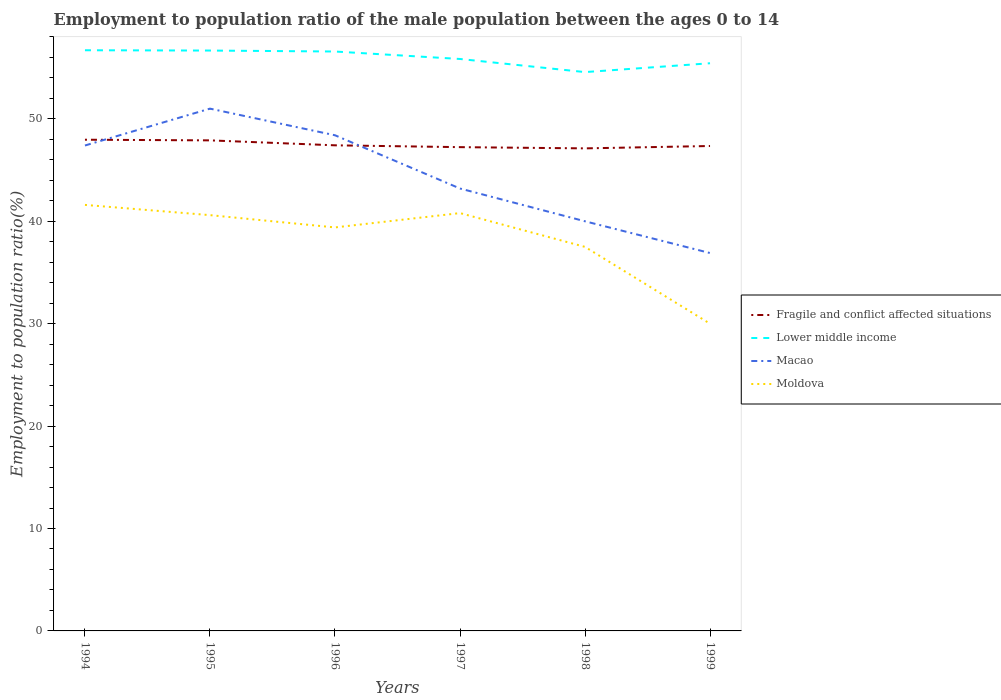Across all years, what is the maximum employment to population ratio in Fragile and conflict affected situations?
Ensure brevity in your answer.  47.12. What is the total employment to population ratio in Moldova in the graph?
Offer a terse response. -0.2. What is the difference between the highest and the second highest employment to population ratio in Macao?
Your response must be concise. 14.1. Is the employment to population ratio in Fragile and conflict affected situations strictly greater than the employment to population ratio in Macao over the years?
Ensure brevity in your answer.  No. What is the difference between two consecutive major ticks on the Y-axis?
Keep it short and to the point. 10. Where does the legend appear in the graph?
Provide a short and direct response. Center right. How many legend labels are there?
Ensure brevity in your answer.  4. How are the legend labels stacked?
Your response must be concise. Vertical. What is the title of the graph?
Your response must be concise. Employment to population ratio of the male population between the ages 0 to 14. What is the Employment to population ratio(%) in Fragile and conflict affected situations in 1994?
Give a very brief answer. 47.96. What is the Employment to population ratio(%) of Lower middle income in 1994?
Provide a short and direct response. 56.7. What is the Employment to population ratio(%) of Macao in 1994?
Your answer should be compact. 47.4. What is the Employment to population ratio(%) of Moldova in 1994?
Offer a terse response. 41.6. What is the Employment to population ratio(%) in Fragile and conflict affected situations in 1995?
Your response must be concise. 47.9. What is the Employment to population ratio(%) of Lower middle income in 1995?
Your answer should be very brief. 56.67. What is the Employment to population ratio(%) in Macao in 1995?
Offer a very short reply. 51. What is the Employment to population ratio(%) of Moldova in 1995?
Provide a succinct answer. 40.6. What is the Employment to population ratio(%) in Fragile and conflict affected situations in 1996?
Offer a very short reply. 47.42. What is the Employment to population ratio(%) in Lower middle income in 1996?
Provide a short and direct response. 56.58. What is the Employment to population ratio(%) in Macao in 1996?
Your answer should be very brief. 48.4. What is the Employment to population ratio(%) in Moldova in 1996?
Give a very brief answer. 39.4. What is the Employment to population ratio(%) in Fragile and conflict affected situations in 1997?
Give a very brief answer. 47.24. What is the Employment to population ratio(%) in Lower middle income in 1997?
Offer a terse response. 55.85. What is the Employment to population ratio(%) of Macao in 1997?
Provide a short and direct response. 43.2. What is the Employment to population ratio(%) in Moldova in 1997?
Ensure brevity in your answer.  40.8. What is the Employment to population ratio(%) of Fragile and conflict affected situations in 1998?
Provide a short and direct response. 47.12. What is the Employment to population ratio(%) in Lower middle income in 1998?
Make the answer very short. 54.57. What is the Employment to population ratio(%) in Macao in 1998?
Offer a very short reply. 40. What is the Employment to population ratio(%) in Moldova in 1998?
Offer a terse response. 37.5. What is the Employment to population ratio(%) of Fragile and conflict affected situations in 1999?
Offer a very short reply. 47.35. What is the Employment to population ratio(%) of Lower middle income in 1999?
Provide a succinct answer. 55.43. What is the Employment to population ratio(%) in Macao in 1999?
Your answer should be very brief. 36.9. Across all years, what is the maximum Employment to population ratio(%) in Fragile and conflict affected situations?
Offer a terse response. 47.96. Across all years, what is the maximum Employment to population ratio(%) of Lower middle income?
Your answer should be compact. 56.7. Across all years, what is the maximum Employment to population ratio(%) in Macao?
Offer a terse response. 51. Across all years, what is the maximum Employment to population ratio(%) in Moldova?
Offer a terse response. 41.6. Across all years, what is the minimum Employment to population ratio(%) of Fragile and conflict affected situations?
Your answer should be compact. 47.12. Across all years, what is the minimum Employment to population ratio(%) of Lower middle income?
Ensure brevity in your answer.  54.57. Across all years, what is the minimum Employment to population ratio(%) in Macao?
Provide a short and direct response. 36.9. Across all years, what is the minimum Employment to population ratio(%) of Moldova?
Make the answer very short. 30. What is the total Employment to population ratio(%) in Fragile and conflict affected situations in the graph?
Give a very brief answer. 284.99. What is the total Employment to population ratio(%) in Lower middle income in the graph?
Offer a very short reply. 335.8. What is the total Employment to population ratio(%) of Macao in the graph?
Your answer should be very brief. 266.9. What is the total Employment to population ratio(%) of Moldova in the graph?
Provide a short and direct response. 229.9. What is the difference between the Employment to population ratio(%) of Fragile and conflict affected situations in 1994 and that in 1995?
Your answer should be very brief. 0.06. What is the difference between the Employment to population ratio(%) of Lower middle income in 1994 and that in 1995?
Ensure brevity in your answer.  0.03. What is the difference between the Employment to population ratio(%) of Fragile and conflict affected situations in 1994 and that in 1996?
Offer a terse response. 0.55. What is the difference between the Employment to population ratio(%) in Lower middle income in 1994 and that in 1996?
Give a very brief answer. 0.12. What is the difference between the Employment to population ratio(%) in Macao in 1994 and that in 1996?
Offer a very short reply. -1. What is the difference between the Employment to population ratio(%) in Fragile and conflict affected situations in 1994 and that in 1997?
Make the answer very short. 0.73. What is the difference between the Employment to population ratio(%) in Lower middle income in 1994 and that in 1997?
Give a very brief answer. 0.85. What is the difference between the Employment to population ratio(%) in Fragile and conflict affected situations in 1994 and that in 1998?
Provide a succinct answer. 0.85. What is the difference between the Employment to population ratio(%) of Lower middle income in 1994 and that in 1998?
Give a very brief answer. 2.13. What is the difference between the Employment to population ratio(%) of Moldova in 1994 and that in 1998?
Provide a succinct answer. 4.1. What is the difference between the Employment to population ratio(%) of Fragile and conflict affected situations in 1994 and that in 1999?
Your answer should be compact. 0.61. What is the difference between the Employment to population ratio(%) of Lower middle income in 1994 and that in 1999?
Offer a very short reply. 1.27. What is the difference between the Employment to population ratio(%) of Macao in 1994 and that in 1999?
Provide a succinct answer. 10.5. What is the difference between the Employment to population ratio(%) in Fragile and conflict affected situations in 1995 and that in 1996?
Your answer should be compact. 0.48. What is the difference between the Employment to population ratio(%) in Lower middle income in 1995 and that in 1996?
Provide a succinct answer. 0.09. What is the difference between the Employment to population ratio(%) in Macao in 1995 and that in 1996?
Make the answer very short. 2.6. What is the difference between the Employment to population ratio(%) of Fragile and conflict affected situations in 1995 and that in 1997?
Your response must be concise. 0.66. What is the difference between the Employment to population ratio(%) of Lower middle income in 1995 and that in 1997?
Your answer should be very brief. 0.82. What is the difference between the Employment to population ratio(%) of Macao in 1995 and that in 1997?
Make the answer very short. 7.8. What is the difference between the Employment to population ratio(%) of Moldova in 1995 and that in 1997?
Keep it short and to the point. -0.2. What is the difference between the Employment to population ratio(%) of Fragile and conflict affected situations in 1995 and that in 1998?
Your answer should be compact. 0.78. What is the difference between the Employment to population ratio(%) in Lower middle income in 1995 and that in 1998?
Offer a very short reply. 2.1. What is the difference between the Employment to population ratio(%) of Macao in 1995 and that in 1998?
Provide a succinct answer. 11. What is the difference between the Employment to population ratio(%) in Moldova in 1995 and that in 1998?
Keep it short and to the point. 3.1. What is the difference between the Employment to population ratio(%) in Fragile and conflict affected situations in 1995 and that in 1999?
Keep it short and to the point. 0.55. What is the difference between the Employment to population ratio(%) in Lower middle income in 1995 and that in 1999?
Your answer should be very brief. 1.24. What is the difference between the Employment to population ratio(%) of Macao in 1995 and that in 1999?
Provide a short and direct response. 14.1. What is the difference between the Employment to population ratio(%) of Fragile and conflict affected situations in 1996 and that in 1997?
Ensure brevity in your answer.  0.18. What is the difference between the Employment to population ratio(%) in Lower middle income in 1996 and that in 1997?
Offer a terse response. 0.73. What is the difference between the Employment to population ratio(%) of Fragile and conflict affected situations in 1996 and that in 1998?
Provide a short and direct response. 0.3. What is the difference between the Employment to population ratio(%) of Lower middle income in 1996 and that in 1998?
Provide a short and direct response. 2.01. What is the difference between the Employment to population ratio(%) in Fragile and conflict affected situations in 1996 and that in 1999?
Your answer should be very brief. 0.07. What is the difference between the Employment to population ratio(%) of Lower middle income in 1996 and that in 1999?
Make the answer very short. 1.15. What is the difference between the Employment to population ratio(%) in Fragile and conflict affected situations in 1997 and that in 1998?
Your answer should be compact. 0.12. What is the difference between the Employment to population ratio(%) of Lower middle income in 1997 and that in 1998?
Keep it short and to the point. 1.28. What is the difference between the Employment to population ratio(%) in Macao in 1997 and that in 1998?
Keep it short and to the point. 3.2. What is the difference between the Employment to population ratio(%) in Moldova in 1997 and that in 1998?
Make the answer very short. 3.3. What is the difference between the Employment to population ratio(%) in Fragile and conflict affected situations in 1997 and that in 1999?
Offer a very short reply. -0.11. What is the difference between the Employment to population ratio(%) in Lower middle income in 1997 and that in 1999?
Keep it short and to the point. 0.42. What is the difference between the Employment to population ratio(%) of Macao in 1997 and that in 1999?
Provide a succinct answer. 6.3. What is the difference between the Employment to population ratio(%) in Fragile and conflict affected situations in 1998 and that in 1999?
Your answer should be very brief. -0.23. What is the difference between the Employment to population ratio(%) of Lower middle income in 1998 and that in 1999?
Provide a short and direct response. -0.86. What is the difference between the Employment to population ratio(%) in Macao in 1998 and that in 1999?
Give a very brief answer. 3.1. What is the difference between the Employment to population ratio(%) of Moldova in 1998 and that in 1999?
Provide a succinct answer. 7.5. What is the difference between the Employment to population ratio(%) in Fragile and conflict affected situations in 1994 and the Employment to population ratio(%) in Lower middle income in 1995?
Give a very brief answer. -8.71. What is the difference between the Employment to population ratio(%) of Fragile and conflict affected situations in 1994 and the Employment to population ratio(%) of Macao in 1995?
Provide a succinct answer. -3.04. What is the difference between the Employment to population ratio(%) of Fragile and conflict affected situations in 1994 and the Employment to population ratio(%) of Moldova in 1995?
Your answer should be very brief. 7.37. What is the difference between the Employment to population ratio(%) of Lower middle income in 1994 and the Employment to population ratio(%) of Macao in 1995?
Make the answer very short. 5.7. What is the difference between the Employment to population ratio(%) of Lower middle income in 1994 and the Employment to population ratio(%) of Moldova in 1995?
Provide a short and direct response. 16.1. What is the difference between the Employment to population ratio(%) in Fragile and conflict affected situations in 1994 and the Employment to population ratio(%) in Lower middle income in 1996?
Give a very brief answer. -8.61. What is the difference between the Employment to population ratio(%) in Fragile and conflict affected situations in 1994 and the Employment to population ratio(%) in Macao in 1996?
Make the answer very short. -0.44. What is the difference between the Employment to population ratio(%) in Fragile and conflict affected situations in 1994 and the Employment to population ratio(%) in Moldova in 1996?
Offer a very short reply. 8.56. What is the difference between the Employment to population ratio(%) of Lower middle income in 1994 and the Employment to population ratio(%) of Macao in 1996?
Your response must be concise. 8.3. What is the difference between the Employment to population ratio(%) in Lower middle income in 1994 and the Employment to population ratio(%) in Moldova in 1996?
Provide a succinct answer. 17.3. What is the difference between the Employment to population ratio(%) in Macao in 1994 and the Employment to population ratio(%) in Moldova in 1996?
Give a very brief answer. 8. What is the difference between the Employment to population ratio(%) of Fragile and conflict affected situations in 1994 and the Employment to population ratio(%) of Lower middle income in 1997?
Offer a terse response. -7.88. What is the difference between the Employment to population ratio(%) of Fragile and conflict affected situations in 1994 and the Employment to population ratio(%) of Macao in 1997?
Make the answer very short. 4.76. What is the difference between the Employment to population ratio(%) in Fragile and conflict affected situations in 1994 and the Employment to population ratio(%) in Moldova in 1997?
Your response must be concise. 7.17. What is the difference between the Employment to population ratio(%) in Lower middle income in 1994 and the Employment to population ratio(%) in Macao in 1997?
Make the answer very short. 13.5. What is the difference between the Employment to population ratio(%) in Lower middle income in 1994 and the Employment to population ratio(%) in Moldova in 1997?
Provide a short and direct response. 15.9. What is the difference between the Employment to population ratio(%) of Macao in 1994 and the Employment to population ratio(%) of Moldova in 1997?
Offer a terse response. 6.6. What is the difference between the Employment to population ratio(%) of Fragile and conflict affected situations in 1994 and the Employment to population ratio(%) of Lower middle income in 1998?
Offer a very short reply. -6.6. What is the difference between the Employment to population ratio(%) of Fragile and conflict affected situations in 1994 and the Employment to population ratio(%) of Macao in 1998?
Your answer should be compact. 7.96. What is the difference between the Employment to population ratio(%) of Fragile and conflict affected situations in 1994 and the Employment to population ratio(%) of Moldova in 1998?
Offer a very short reply. 10.46. What is the difference between the Employment to population ratio(%) of Lower middle income in 1994 and the Employment to population ratio(%) of Macao in 1998?
Provide a short and direct response. 16.7. What is the difference between the Employment to population ratio(%) in Lower middle income in 1994 and the Employment to population ratio(%) in Moldova in 1998?
Keep it short and to the point. 19.2. What is the difference between the Employment to population ratio(%) in Macao in 1994 and the Employment to population ratio(%) in Moldova in 1998?
Your answer should be very brief. 9.9. What is the difference between the Employment to population ratio(%) in Fragile and conflict affected situations in 1994 and the Employment to population ratio(%) in Lower middle income in 1999?
Your answer should be very brief. -7.47. What is the difference between the Employment to population ratio(%) in Fragile and conflict affected situations in 1994 and the Employment to population ratio(%) in Macao in 1999?
Provide a succinct answer. 11.06. What is the difference between the Employment to population ratio(%) of Fragile and conflict affected situations in 1994 and the Employment to population ratio(%) of Moldova in 1999?
Offer a very short reply. 17.96. What is the difference between the Employment to population ratio(%) in Lower middle income in 1994 and the Employment to population ratio(%) in Macao in 1999?
Keep it short and to the point. 19.8. What is the difference between the Employment to population ratio(%) in Lower middle income in 1994 and the Employment to population ratio(%) in Moldova in 1999?
Your answer should be compact. 26.7. What is the difference between the Employment to population ratio(%) in Fragile and conflict affected situations in 1995 and the Employment to population ratio(%) in Lower middle income in 1996?
Provide a short and direct response. -8.68. What is the difference between the Employment to population ratio(%) in Fragile and conflict affected situations in 1995 and the Employment to population ratio(%) in Macao in 1996?
Make the answer very short. -0.5. What is the difference between the Employment to population ratio(%) of Fragile and conflict affected situations in 1995 and the Employment to population ratio(%) of Moldova in 1996?
Ensure brevity in your answer.  8.5. What is the difference between the Employment to population ratio(%) in Lower middle income in 1995 and the Employment to population ratio(%) in Macao in 1996?
Give a very brief answer. 8.27. What is the difference between the Employment to population ratio(%) in Lower middle income in 1995 and the Employment to population ratio(%) in Moldova in 1996?
Offer a very short reply. 17.27. What is the difference between the Employment to population ratio(%) in Macao in 1995 and the Employment to population ratio(%) in Moldova in 1996?
Provide a succinct answer. 11.6. What is the difference between the Employment to population ratio(%) in Fragile and conflict affected situations in 1995 and the Employment to population ratio(%) in Lower middle income in 1997?
Offer a very short reply. -7.95. What is the difference between the Employment to population ratio(%) of Fragile and conflict affected situations in 1995 and the Employment to population ratio(%) of Macao in 1997?
Offer a terse response. 4.7. What is the difference between the Employment to population ratio(%) of Fragile and conflict affected situations in 1995 and the Employment to population ratio(%) of Moldova in 1997?
Provide a short and direct response. 7.1. What is the difference between the Employment to population ratio(%) of Lower middle income in 1995 and the Employment to population ratio(%) of Macao in 1997?
Your response must be concise. 13.47. What is the difference between the Employment to population ratio(%) of Lower middle income in 1995 and the Employment to population ratio(%) of Moldova in 1997?
Your answer should be compact. 15.87. What is the difference between the Employment to population ratio(%) in Fragile and conflict affected situations in 1995 and the Employment to population ratio(%) in Lower middle income in 1998?
Your answer should be compact. -6.67. What is the difference between the Employment to population ratio(%) in Fragile and conflict affected situations in 1995 and the Employment to population ratio(%) in Macao in 1998?
Your response must be concise. 7.9. What is the difference between the Employment to population ratio(%) of Fragile and conflict affected situations in 1995 and the Employment to population ratio(%) of Moldova in 1998?
Provide a short and direct response. 10.4. What is the difference between the Employment to population ratio(%) of Lower middle income in 1995 and the Employment to population ratio(%) of Macao in 1998?
Offer a very short reply. 16.67. What is the difference between the Employment to population ratio(%) of Lower middle income in 1995 and the Employment to population ratio(%) of Moldova in 1998?
Your answer should be compact. 19.17. What is the difference between the Employment to population ratio(%) of Fragile and conflict affected situations in 1995 and the Employment to population ratio(%) of Lower middle income in 1999?
Provide a succinct answer. -7.53. What is the difference between the Employment to population ratio(%) in Fragile and conflict affected situations in 1995 and the Employment to population ratio(%) in Macao in 1999?
Make the answer very short. 11. What is the difference between the Employment to population ratio(%) in Fragile and conflict affected situations in 1995 and the Employment to population ratio(%) in Moldova in 1999?
Offer a very short reply. 17.9. What is the difference between the Employment to population ratio(%) of Lower middle income in 1995 and the Employment to population ratio(%) of Macao in 1999?
Ensure brevity in your answer.  19.77. What is the difference between the Employment to population ratio(%) in Lower middle income in 1995 and the Employment to population ratio(%) in Moldova in 1999?
Offer a very short reply. 26.67. What is the difference between the Employment to population ratio(%) in Fragile and conflict affected situations in 1996 and the Employment to population ratio(%) in Lower middle income in 1997?
Offer a very short reply. -8.43. What is the difference between the Employment to population ratio(%) in Fragile and conflict affected situations in 1996 and the Employment to population ratio(%) in Macao in 1997?
Give a very brief answer. 4.22. What is the difference between the Employment to population ratio(%) of Fragile and conflict affected situations in 1996 and the Employment to population ratio(%) of Moldova in 1997?
Your answer should be very brief. 6.62. What is the difference between the Employment to population ratio(%) of Lower middle income in 1996 and the Employment to population ratio(%) of Macao in 1997?
Your response must be concise. 13.38. What is the difference between the Employment to population ratio(%) in Lower middle income in 1996 and the Employment to population ratio(%) in Moldova in 1997?
Provide a short and direct response. 15.78. What is the difference between the Employment to population ratio(%) in Fragile and conflict affected situations in 1996 and the Employment to population ratio(%) in Lower middle income in 1998?
Make the answer very short. -7.15. What is the difference between the Employment to population ratio(%) in Fragile and conflict affected situations in 1996 and the Employment to population ratio(%) in Macao in 1998?
Keep it short and to the point. 7.42. What is the difference between the Employment to population ratio(%) in Fragile and conflict affected situations in 1996 and the Employment to population ratio(%) in Moldova in 1998?
Give a very brief answer. 9.92. What is the difference between the Employment to population ratio(%) in Lower middle income in 1996 and the Employment to population ratio(%) in Macao in 1998?
Ensure brevity in your answer.  16.58. What is the difference between the Employment to population ratio(%) of Lower middle income in 1996 and the Employment to population ratio(%) of Moldova in 1998?
Offer a terse response. 19.08. What is the difference between the Employment to population ratio(%) of Macao in 1996 and the Employment to population ratio(%) of Moldova in 1998?
Keep it short and to the point. 10.9. What is the difference between the Employment to population ratio(%) of Fragile and conflict affected situations in 1996 and the Employment to population ratio(%) of Lower middle income in 1999?
Offer a very short reply. -8.01. What is the difference between the Employment to population ratio(%) of Fragile and conflict affected situations in 1996 and the Employment to population ratio(%) of Macao in 1999?
Make the answer very short. 10.52. What is the difference between the Employment to population ratio(%) in Fragile and conflict affected situations in 1996 and the Employment to population ratio(%) in Moldova in 1999?
Give a very brief answer. 17.42. What is the difference between the Employment to population ratio(%) in Lower middle income in 1996 and the Employment to population ratio(%) in Macao in 1999?
Ensure brevity in your answer.  19.68. What is the difference between the Employment to population ratio(%) of Lower middle income in 1996 and the Employment to population ratio(%) of Moldova in 1999?
Provide a short and direct response. 26.58. What is the difference between the Employment to population ratio(%) in Macao in 1996 and the Employment to population ratio(%) in Moldova in 1999?
Ensure brevity in your answer.  18.4. What is the difference between the Employment to population ratio(%) in Fragile and conflict affected situations in 1997 and the Employment to population ratio(%) in Lower middle income in 1998?
Give a very brief answer. -7.33. What is the difference between the Employment to population ratio(%) of Fragile and conflict affected situations in 1997 and the Employment to population ratio(%) of Macao in 1998?
Provide a succinct answer. 7.24. What is the difference between the Employment to population ratio(%) in Fragile and conflict affected situations in 1997 and the Employment to population ratio(%) in Moldova in 1998?
Give a very brief answer. 9.74. What is the difference between the Employment to population ratio(%) in Lower middle income in 1997 and the Employment to population ratio(%) in Macao in 1998?
Offer a terse response. 15.85. What is the difference between the Employment to population ratio(%) of Lower middle income in 1997 and the Employment to population ratio(%) of Moldova in 1998?
Your answer should be very brief. 18.35. What is the difference between the Employment to population ratio(%) in Fragile and conflict affected situations in 1997 and the Employment to population ratio(%) in Lower middle income in 1999?
Provide a short and direct response. -8.19. What is the difference between the Employment to population ratio(%) of Fragile and conflict affected situations in 1997 and the Employment to population ratio(%) of Macao in 1999?
Make the answer very short. 10.34. What is the difference between the Employment to population ratio(%) of Fragile and conflict affected situations in 1997 and the Employment to population ratio(%) of Moldova in 1999?
Provide a succinct answer. 17.24. What is the difference between the Employment to population ratio(%) of Lower middle income in 1997 and the Employment to population ratio(%) of Macao in 1999?
Offer a terse response. 18.95. What is the difference between the Employment to population ratio(%) in Lower middle income in 1997 and the Employment to population ratio(%) in Moldova in 1999?
Make the answer very short. 25.85. What is the difference between the Employment to population ratio(%) in Fragile and conflict affected situations in 1998 and the Employment to population ratio(%) in Lower middle income in 1999?
Ensure brevity in your answer.  -8.31. What is the difference between the Employment to population ratio(%) of Fragile and conflict affected situations in 1998 and the Employment to population ratio(%) of Macao in 1999?
Give a very brief answer. 10.22. What is the difference between the Employment to population ratio(%) in Fragile and conflict affected situations in 1998 and the Employment to population ratio(%) in Moldova in 1999?
Provide a succinct answer. 17.12. What is the difference between the Employment to population ratio(%) in Lower middle income in 1998 and the Employment to population ratio(%) in Macao in 1999?
Give a very brief answer. 17.67. What is the difference between the Employment to population ratio(%) of Lower middle income in 1998 and the Employment to population ratio(%) of Moldova in 1999?
Ensure brevity in your answer.  24.57. What is the difference between the Employment to population ratio(%) of Macao in 1998 and the Employment to population ratio(%) of Moldova in 1999?
Provide a short and direct response. 10. What is the average Employment to population ratio(%) in Fragile and conflict affected situations per year?
Ensure brevity in your answer.  47.5. What is the average Employment to population ratio(%) in Lower middle income per year?
Keep it short and to the point. 55.97. What is the average Employment to population ratio(%) in Macao per year?
Offer a very short reply. 44.48. What is the average Employment to population ratio(%) in Moldova per year?
Give a very brief answer. 38.32. In the year 1994, what is the difference between the Employment to population ratio(%) of Fragile and conflict affected situations and Employment to population ratio(%) of Lower middle income?
Your answer should be compact. -8.74. In the year 1994, what is the difference between the Employment to population ratio(%) in Fragile and conflict affected situations and Employment to population ratio(%) in Macao?
Provide a short and direct response. 0.56. In the year 1994, what is the difference between the Employment to population ratio(%) of Fragile and conflict affected situations and Employment to population ratio(%) of Moldova?
Ensure brevity in your answer.  6.37. In the year 1994, what is the difference between the Employment to population ratio(%) in Lower middle income and Employment to population ratio(%) in Macao?
Provide a succinct answer. 9.3. In the year 1994, what is the difference between the Employment to population ratio(%) of Lower middle income and Employment to population ratio(%) of Moldova?
Your answer should be very brief. 15.1. In the year 1994, what is the difference between the Employment to population ratio(%) of Macao and Employment to population ratio(%) of Moldova?
Provide a succinct answer. 5.8. In the year 1995, what is the difference between the Employment to population ratio(%) of Fragile and conflict affected situations and Employment to population ratio(%) of Lower middle income?
Provide a succinct answer. -8.77. In the year 1995, what is the difference between the Employment to population ratio(%) in Fragile and conflict affected situations and Employment to population ratio(%) in Macao?
Your response must be concise. -3.1. In the year 1995, what is the difference between the Employment to population ratio(%) of Fragile and conflict affected situations and Employment to population ratio(%) of Moldova?
Provide a succinct answer. 7.3. In the year 1995, what is the difference between the Employment to population ratio(%) in Lower middle income and Employment to population ratio(%) in Macao?
Give a very brief answer. 5.67. In the year 1995, what is the difference between the Employment to population ratio(%) in Lower middle income and Employment to population ratio(%) in Moldova?
Your answer should be compact. 16.07. In the year 1995, what is the difference between the Employment to population ratio(%) in Macao and Employment to population ratio(%) in Moldova?
Offer a very short reply. 10.4. In the year 1996, what is the difference between the Employment to population ratio(%) of Fragile and conflict affected situations and Employment to population ratio(%) of Lower middle income?
Offer a terse response. -9.16. In the year 1996, what is the difference between the Employment to population ratio(%) in Fragile and conflict affected situations and Employment to population ratio(%) in Macao?
Make the answer very short. -0.98. In the year 1996, what is the difference between the Employment to population ratio(%) in Fragile and conflict affected situations and Employment to population ratio(%) in Moldova?
Offer a terse response. 8.02. In the year 1996, what is the difference between the Employment to population ratio(%) in Lower middle income and Employment to population ratio(%) in Macao?
Make the answer very short. 8.18. In the year 1996, what is the difference between the Employment to population ratio(%) of Lower middle income and Employment to population ratio(%) of Moldova?
Make the answer very short. 17.18. In the year 1996, what is the difference between the Employment to population ratio(%) of Macao and Employment to population ratio(%) of Moldova?
Offer a terse response. 9. In the year 1997, what is the difference between the Employment to population ratio(%) in Fragile and conflict affected situations and Employment to population ratio(%) in Lower middle income?
Your response must be concise. -8.61. In the year 1997, what is the difference between the Employment to population ratio(%) of Fragile and conflict affected situations and Employment to population ratio(%) of Macao?
Offer a very short reply. 4.04. In the year 1997, what is the difference between the Employment to population ratio(%) in Fragile and conflict affected situations and Employment to population ratio(%) in Moldova?
Your answer should be compact. 6.44. In the year 1997, what is the difference between the Employment to population ratio(%) of Lower middle income and Employment to population ratio(%) of Macao?
Your answer should be very brief. 12.65. In the year 1997, what is the difference between the Employment to population ratio(%) of Lower middle income and Employment to population ratio(%) of Moldova?
Offer a very short reply. 15.05. In the year 1997, what is the difference between the Employment to population ratio(%) in Macao and Employment to population ratio(%) in Moldova?
Provide a succinct answer. 2.4. In the year 1998, what is the difference between the Employment to population ratio(%) in Fragile and conflict affected situations and Employment to population ratio(%) in Lower middle income?
Provide a short and direct response. -7.45. In the year 1998, what is the difference between the Employment to population ratio(%) of Fragile and conflict affected situations and Employment to population ratio(%) of Macao?
Keep it short and to the point. 7.12. In the year 1998, what is the difference between the Employment to population ratio(%) of Fragile and conflict affected situations and Employment to population ratio(%) of Moldova?
Give a very brief answer. 9.62. In the year 1998, what is the difference between the Employment to population ratio(%) in Lower middle income and Employment to population ratio(%) in Macao?
Offer a terse response. 14.57. In the year 1998, what is the difference between the Employment to population ratio(%) in Lower middle income and Employment to population ratio(%) in Moldova?
Your answer should be compact. 17.07. In the year 1999, what is the difference between the Employment to population ratio(%) in Fragile and conflict affected situations and Employment to population ratio(%) in Lower middle income?
Offer a terse response. -8.08. In the year 1999, what is the difference between the Employment to population ratio(%) in Fragile and conflict affected situations and Employment to population ratio(%) in Macao?
Give a very brief answer. 10.45. In the year 1999, what is the difference between the Employment to population ratio(%) in Fragile and conflict affected situations and Employment to population ratio(%) in Moldova?
Offer a very short reply. 17.35. In the year 1999, what is the difference between the Employment to population ratio(%) in Lower middle income and Employment to population ratio(%) in Macao?
Offer a very short reply. 18.53. In the year 1999, what is the difference between the Employment to population ratio(%) of Lower middle income and Employment to population ratio(%) of Moldova?
Offer a terse response. 25.43. What is the ratio of the Employment to population ratio(%) of Fragile and conflict affected situations in 1994 to that in 1995?
Make the answer very short. 1. What is the ratio of the Employment to population ratio(%) in Lower middle income in 1994 to that in 1995?
Offer a terse response. 1. What is the ratio of the Employment to population ratio(%) of Macao in 1994 to that in 1995?
Your answer should be very brief. 0.93. What is the ratio of the Employment to population ratio(%) in Moldova in 1994 to that in 1995?
Your answer should be very brief. 1.02. What is the ratio of the Employment to population ratio(%) in Fragile and conflict affected situations in 1994 to that in 1996?
Your answer should be very brief. 1.01. What is the ratio of the Employment to population ratio(%) in Lower middle income in 1994 to that in 1996?
Your response must be concise. 1. What is the ratio of the Employment to population ratio(%) of Macao in 1994 to that in 1996?
Provide a succinct answer. 0.98. What is the ratio of the Employment to population ratio(%) in Moldova in 1994 to that in 1996?
Give a very brief answer. 1.06. What is the ratio of the Employment to population ratio(%) in Fragile and conflict affected situations in 1994 to that in 1997?
Provide a short and direct response. 1.02. What is the ratio of the Employment to population ratio(%) in Lower middle income in 1994 to that in 1997?
Offer a terse response. 1.02. What is the ratio of the Employment to population ratio(%) of Macao in 1994 to that in 1997?
Offer a terse response. 1.1. What is the ratio of the Employment to population ratio(%) of Moldova in 1994 to that in 1997?
Provide a short and direct response. 1.02. What is the ratio of the Employment to population ratio(%) in Fragile and conflict affected situations in 1994 to that in 1998?
Offer a very short reply. 1.02. What is the ratio of the Employment to population ratio(%) of Lower middle income in 1994 to that in 1998?
Your answer should be compact. 1.04. What is the ratio of the Employment to population ratio(%) of Macao in 1994 to that in 1998?
Offer a terse response. 1.19. What is the ratio of the Employment to population ratio(%) of Moldova in 1994 to that in 1998?
Give a very brief answer. 1.11. What is the ratio of the Employment to population ratio(%) in Lower middle income in 1994 to that in 1999?
Ensure brevity in your answer.  1.02. What is the ratio of the Employment to population ratio(%) of Macao in 1994 to that in 1999?
Keep it short and to the point. 1.28. What is the ratio of the Employment to population ratio(%) in Moldova in 1994 to that in 1999?
Keep it short and to the point. 1.39. What is the ratio of the Employment to population ratio(%) in Fragile and conflict affected situations in 1995 to that in 1996?
Ensure brevity in your answer.  1.01. What is the ratio of the Employment to population ratio(%) in Lower middle income in 1995 to that in 1996?
Keep it short and to the point. 1. What is the ratio of the Employment to population ratio(%) in Macao in 1995 to that in 1996?
Offer a terse response. 1.05. What is the ratio of the Employment to population ratio(%) in Moldova in 1995 to that in 1996?
Provide a short and direct response. 1.03. What is the ratio of the Employment to population ratio(%) of Fragile and conflict affected situations in 1995 to that in 1997?
Ensure brevity in your answer.  1.01. What is the ratio of the Employment to population ratio(%) in Lower middle income in 1995 to that in 1997?
Your answer should be compact. 1.01. What is the ratio of the Employment to population ratio(%) in Macao in 1995 to that in 1997?
Your answer should be very brief. 1.18. What is the ratio of the Employment to population ratio(%) of Moldova in 1995 to that in 1997?
Ensure brevity in your answer.  1. What is the ratio of the Employment to population ratio(%) in Fragile and conflict affected situations in 1995 to that in 1998?
Offer a very short reply. 1.02. What is the ratio of the Employment to population ratio(%) of Macao in 1995 to that in 1998?
Provide a short and direct response. 1.27. What is the ratio of the Employment to population ratio(%) in Moldova in 1995 to that in 1998?
Give a very brief answer. 1.08. What is the ratio of the Employment to population ratio(%) of Fragile and conflict affected situations in 1995 to that in 1999?
Make the answer very short. 1.01. What is the ratio of the Employment to population ratio(%) of Lower middle income in 1995 to that in 1999?
Your answer should be very brief. 1.02. What is the ratio of the Employment to population ratio(%) of Macao in 1995 to that in 1999?
Ensure brevity in your answer.  1.38. What is the ratio of the Employment to population ratio(%) of Moldova in 1995 to that in 1999?
Keep it short and to the point. 1.35. What is the ratio of the Employment to population ratio(%) of Lower middle income in 1996 to that in 1997?
Make the answer very short. 1.01. What is the ratio of the Employment to population ratio(%) of Macao in 1996 to that in 1997?
Ensure brevity in your answer.  1.12. What is the ratio of the Employment to population ratio(%) in Moldova in 1996 to that in 1997?
Offer a very short reply. 0.97. What is the ratio of the Employment to population ratio(%) in Lower middle income in 1996 to that in 1998?
Your response must be concise. 1.04. What is the ratio of the Employment to population ratio(%) in Macao in 1996 to that in 1998?
Offer a terse response. 1.21. What is the ratio of the Employment to population ratio(%) of Moldova in 1996 to that in 1998?
Your answer should be very brief. 1.05. What is the ratio of the Employment to population ratio(%) of Fragile and conflict affected situations in 1996 to that in 1999?
Offer a terse response. 1. What is the ratio of the Employment to population ratio(%) in Lower middle income in 1996 to that in 1999?
Give a very brief answer. 1.02. What is the ratio of the Employment to population ratio(%) of Macao in 1996 to that in 1999?
Make the answer very short. 1.31. What is the ratio of the Employment to population ratio(%) in Moldova in 1996 to that in 1999?
Your response must be concise. 1.31. What is the ratio of the Employment to population ratio(%) of Fragile and conflict affected situations in 1997 to that in 1998?
Keep it short and to the point. 1. What is the ratio of the Employment to population ratio(%) of Lower middle income in 1997 to that in 1998?
Ensure brevity in your answer.  1.02. What is the ratio of the Employment to population ratio(%) in Macao in 1997 to that in 1998?
Your answer should be compact. 1.08. What is the ratio of the Employment to population ratio(%) in Moldova in 1997 to that in 1998?
Your answer should be compact. 1.09. What is the ratio of the Employment to population ratio(%) of Fragile and conflict affected situations in 1997 to that in 1999?
Ensure brevity in your answer.  1. What is the ratio of the Employment to population ratio(%) of Lower middle income in 1997 to that in 1999?
Give a very brief answer. 1.01. What is the ratio of the Employment to population ratio(%) of Macao in 1997 to that in 1999?
Make the answer very short. 1.17. What is the ratio of the Employment to population ratio(%) in Moldova in 1997 to that in 1999?
Your response must be concise. 1.36. What is the ratio of the Employment to population ratio(%) in Lower middle income in 1998 to that in 1999?
Offer a very short reply. 0.98. What is the ratio of the Employment to population ratio(%) of Macao in 1998 to that in 1999?
Your answer should be very brief. 1.08. What is the difference between the highest and the second highest Employment to population ratio(%) of Fragile and conflict affected situations?
Provide a succinct answer. 0.06. What is the difference between the highest and the second highest Employment to population ratio(%) of Lower middle income?
Ensure brevity in your answer.  0.03. What is the difference between the highest and the lowest Employment to population ratio(%) of Fragile and conflict affected situations?
Offer a very short reply. 0.85. What is the difference between the highest and the lowest Employment to population ratio(%) of Lower middle income?
Give a very brief answer. 2.13. What is the difference between the highest and the lowest Employment to population ratio(%) of Macao?
Your answer should be compact. 14.1. 